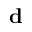<formula> <loc_0><loc_0><loc_500><loc_500>d</formula> 